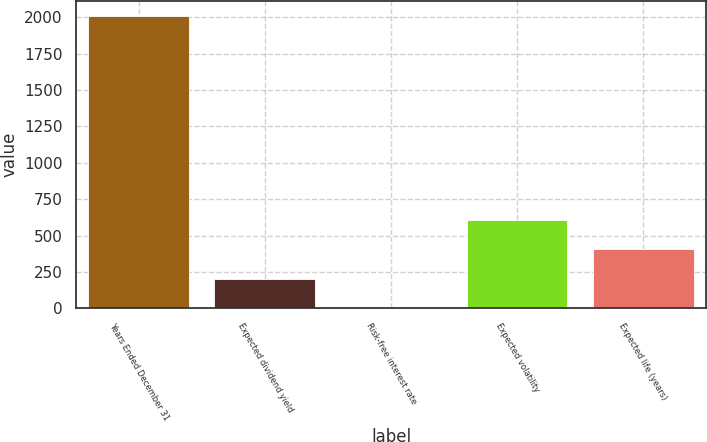<chart> <loc_0><loc_0><loc_500><loc_500><bar_chart><fcel>Years Ended December 31<fcel>Expected dividend yield<fcel>Risk-free interest rate<fcel>Expected volatility<fcel>Expected life (years)<nl><fcel>2011<fcel>203.35<fcel>2.5<fcel>605.05<fcel>404.2<nl></chart> 